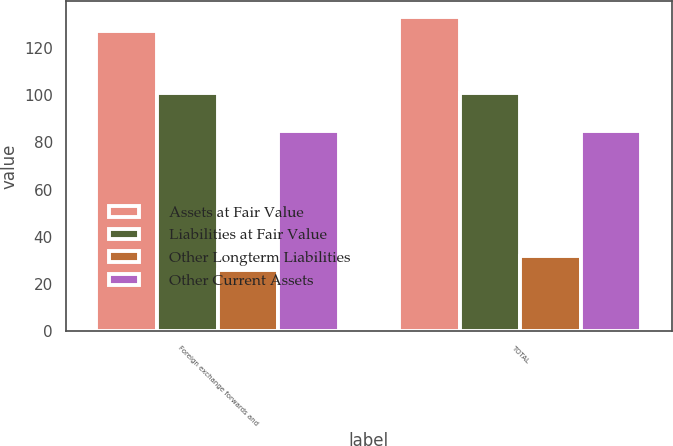Convert chart to OTSL. <chart><loc_0><loc_0><loc_500><loc_500><stacked_bar_chart><ecel><fcel>Foreign exchange forwards and<fcel>TOTAL<nl><fcel>Assets at Fair Value<fcel>127<fcel>133<nl><fcel>Liabilities at Fair Value<fcel>101<fcel>101<nl><fcel>Other Longterm Liabilities<fcel>26<fcel>32<nl><fcel>Other Current Assets<fcel>85<fcel>85<nl></chart> 